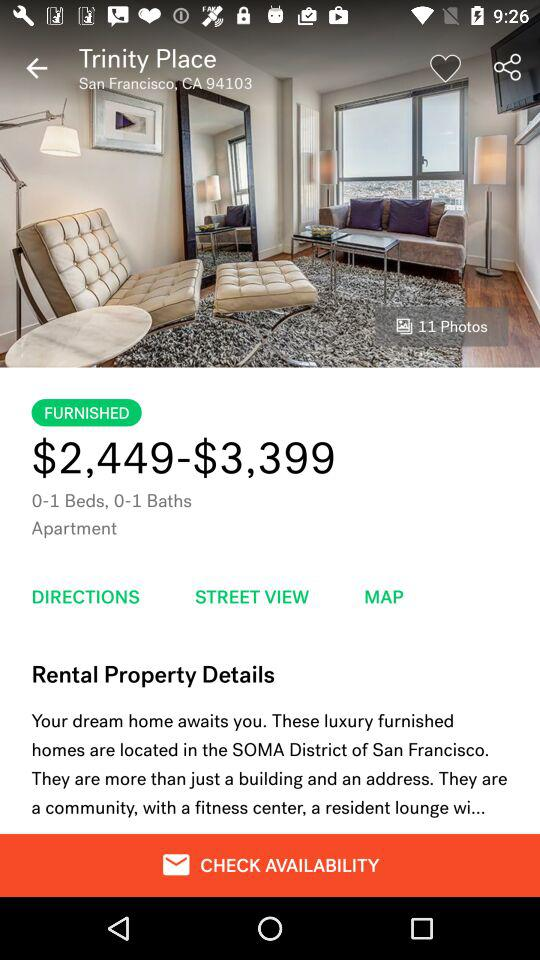How many photos are there? There are 11 photos. 